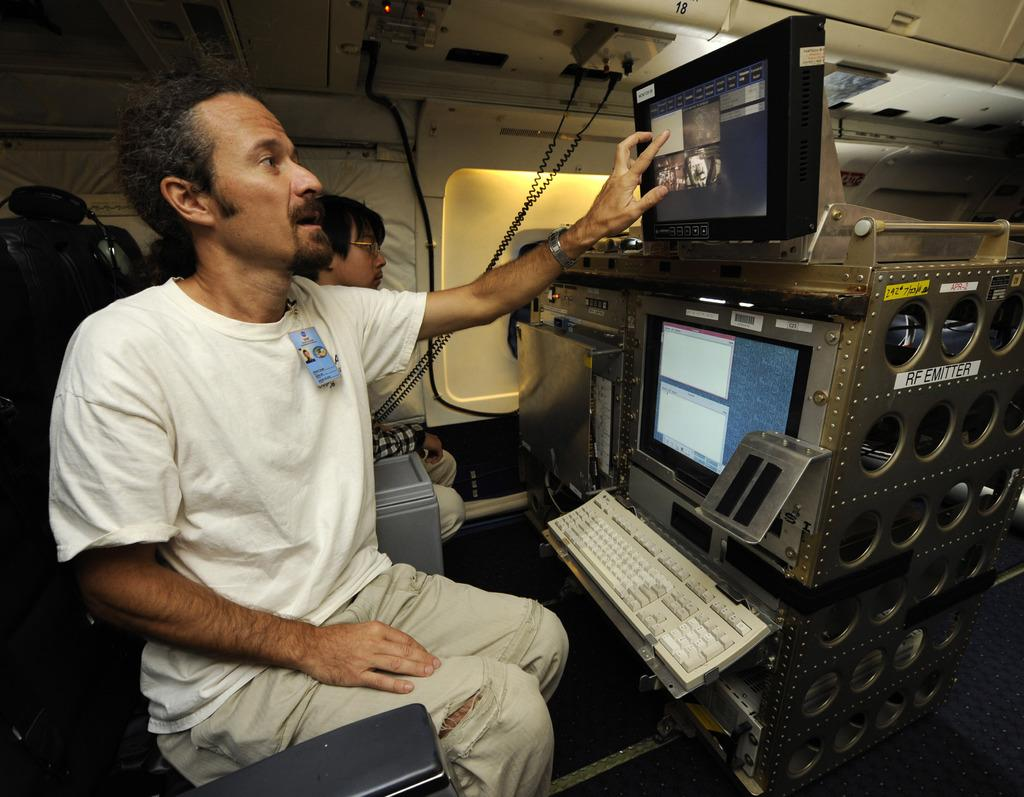<image>
Share a concise interpretation of the image provided. a person inside an airplane in front of a computer console with the words RF Emitter on it 